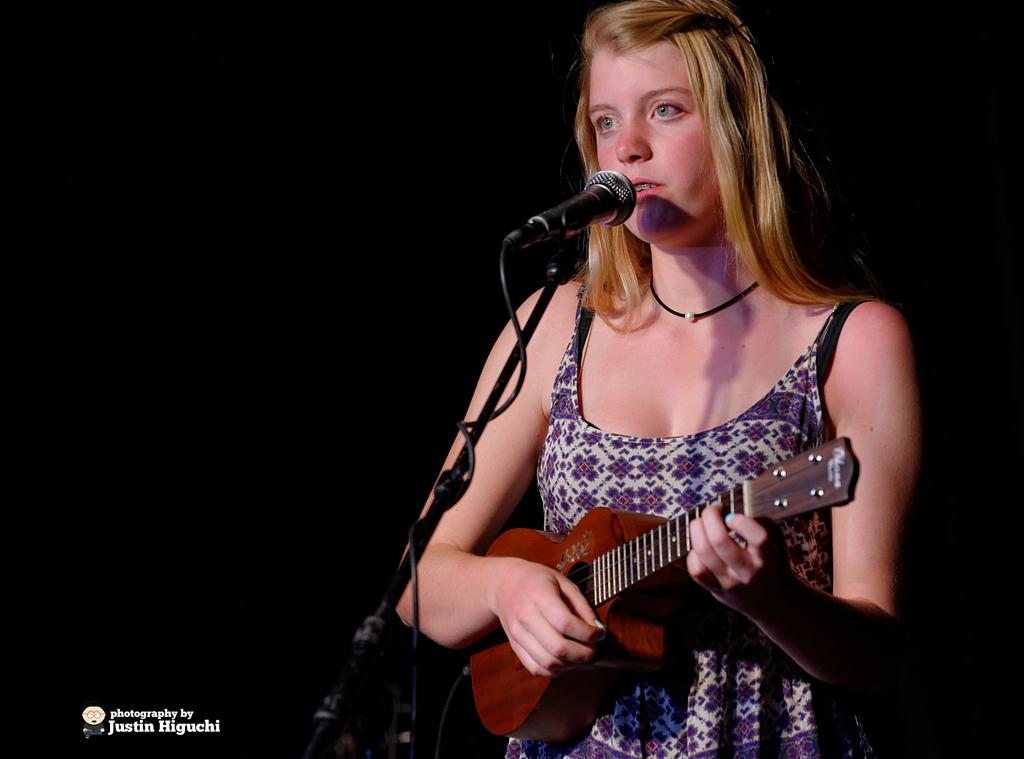Who is the main subject in the picture? There is a girl in the picture. What is the girl doing in the image? The girl is singing and playing a small guitar. Can you describe the girl's attire in the image? The girl is wearing a blue gown. How many flies can be seen buzzing around the girl in the image? There are no flies visible in the image. What type of office furniture is present in the image? There is no office furniture present in the image; it features a girl singing and playing a small guitar. 